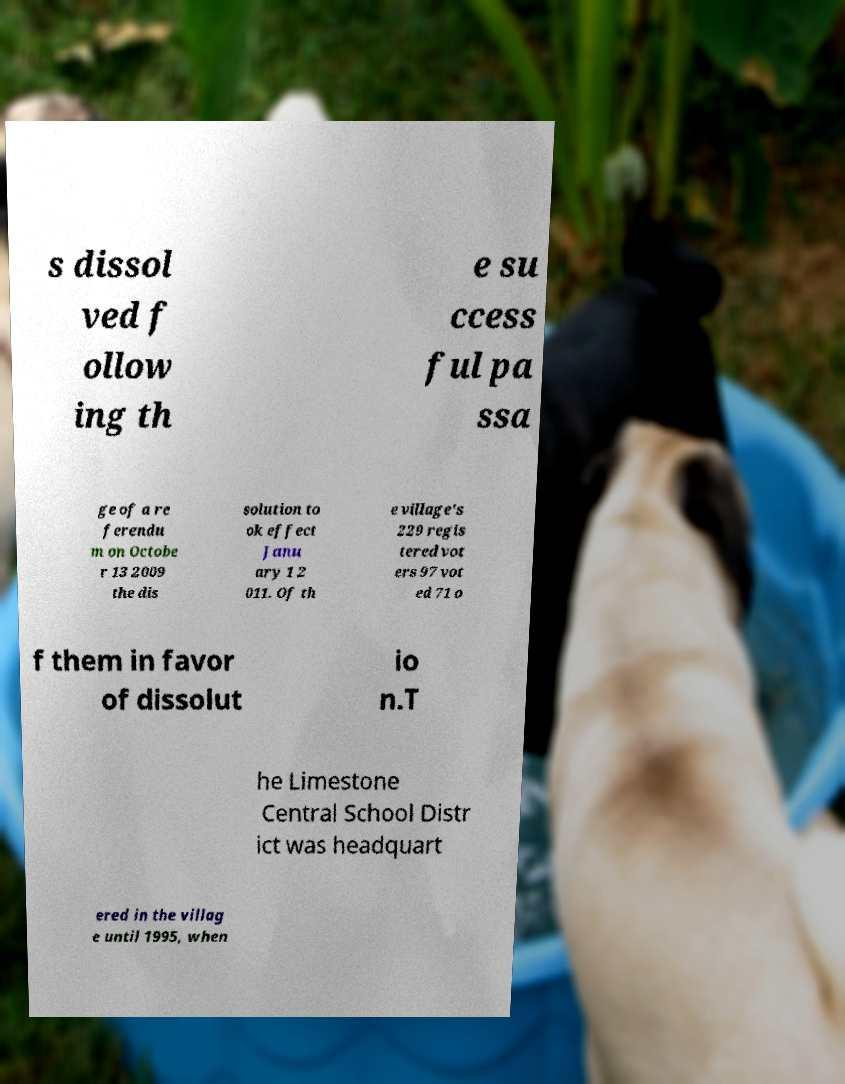For documentation purposes, I need the text within this image transcribed. Could you provide that? s dissol ved f ollow ing th e su ccess ful pa ssa ge of a re ferendu m on Octobe r 13 2009 the dis solution to ok effect Janu ary 1 2 011. Of th e village's 229 regis tered vot ers 97 vot ed 71 o f them in favor of dissolut io n.T he Limestone Central School Distr ict was headquart ered in the villag e until 1995, when 